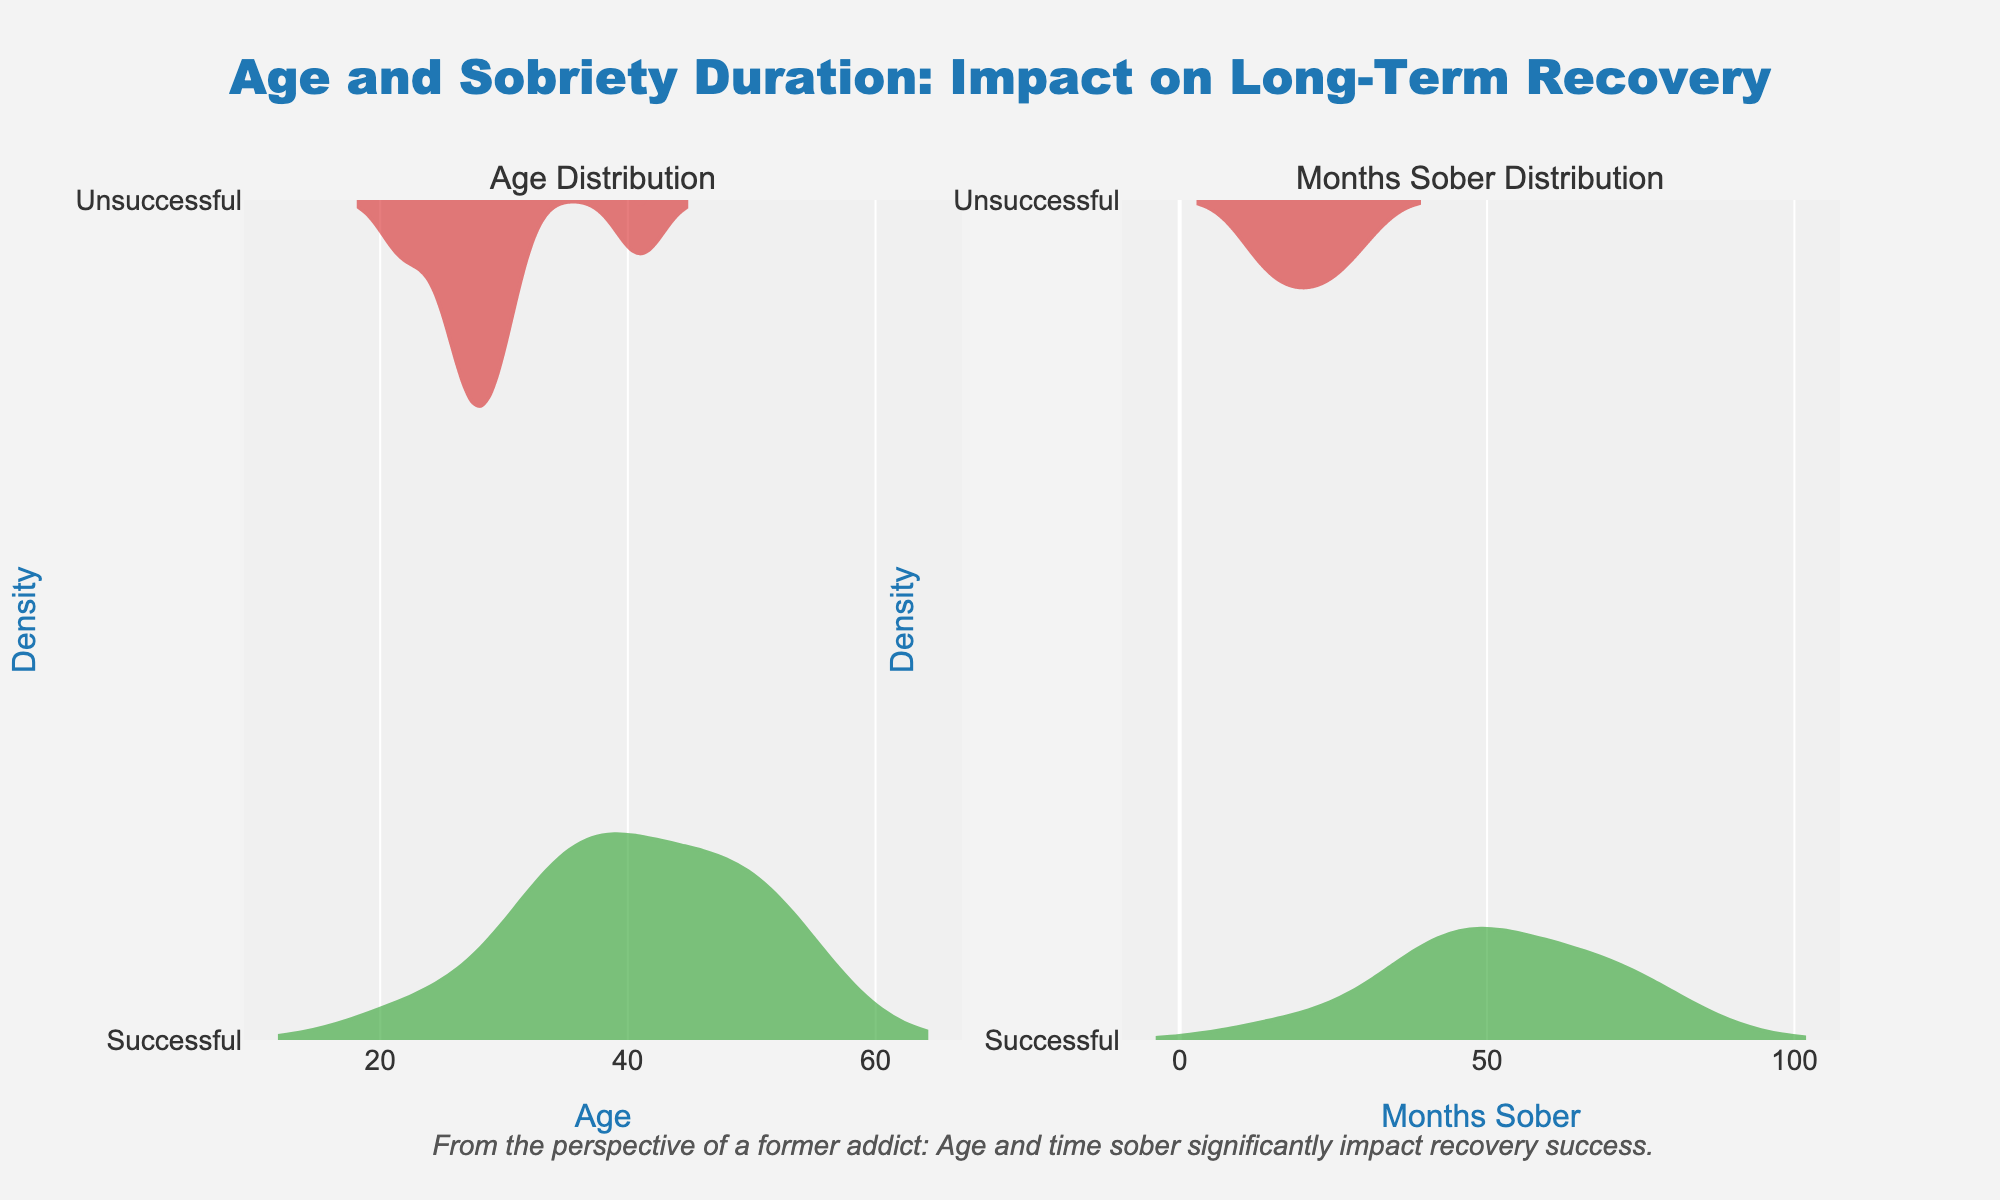What's the main title of the figure? The title is centrally located at the top of the figure, and it reads "Age and Sobriety Duration: Impact on Long-Term Recovery".
Answer: Age and Sobriety Duration: Impact on Long-Term Recovery What do the colors green and red represent in the figure? The figure uses two colors: green and red. Green represents 'Successful' recoveries and red represents 'Unsuccessful' recoveries.
Answer: Green represents 'Successful' recoveries, red represents 'Unsuccessful' recoveries Which subplot shows the Age distribution? The figure is divided into two subplots, with the Age distribution shown on the left side, labeled "Age Distribution".
Answer: The left subplot labeled "Age Distribution" Do younger or older participants tend to have a higher success rate in long-term recovery? From the age distribution plot on the left, it is observed that successful recoveries (shown in green) are more concentrated in the middle to older age groups, indicating that these age groups have a higher success rate.
Answer: Middle to older age groups Is there a noticeable difference in Months Sober distribution between successful and unsuccessful participants? The Months Sober Distribution on the right shows a clear distinction: successful participants (in green) tend to have a higher number of months sober compared to unsuccessful participants (in red).
Answer: Yes, successful participants tend to have more months sober What observation can be made about participants aged below 25? From the age distribution plot, participants aged below 25 are more represented in the unsuccessful recovery (shown in red) category than in the successful one.
Answer: More represented in unsuccessful recovery What annotation is included in the figure? At the bottom, there is an annotation that states, "From the perspective of a former addict: Age and time sober significantly impact recovery success."
Answer: "From the perspective of a former addict: Age and time sober significantly impact recovery success." What is the relationship between age and successful long-term recovery in this figure? Observing the age distribution, older age groups have higher long-term recovery success rates (green) compared to younger age groups, who are more likely to be in the unsuccessful category (red).
Answer: Older age groups have higher success rates Do participants with less than 20 months sober have a higher likelihood of successful long-term recovery? The Months Sober Distribution shows that participants with less than 20 months sober mainly fall into the unsuccessful category (red), indicating that their likelihood of long-term recovery success is lower.
Answer: Lower likelihood 